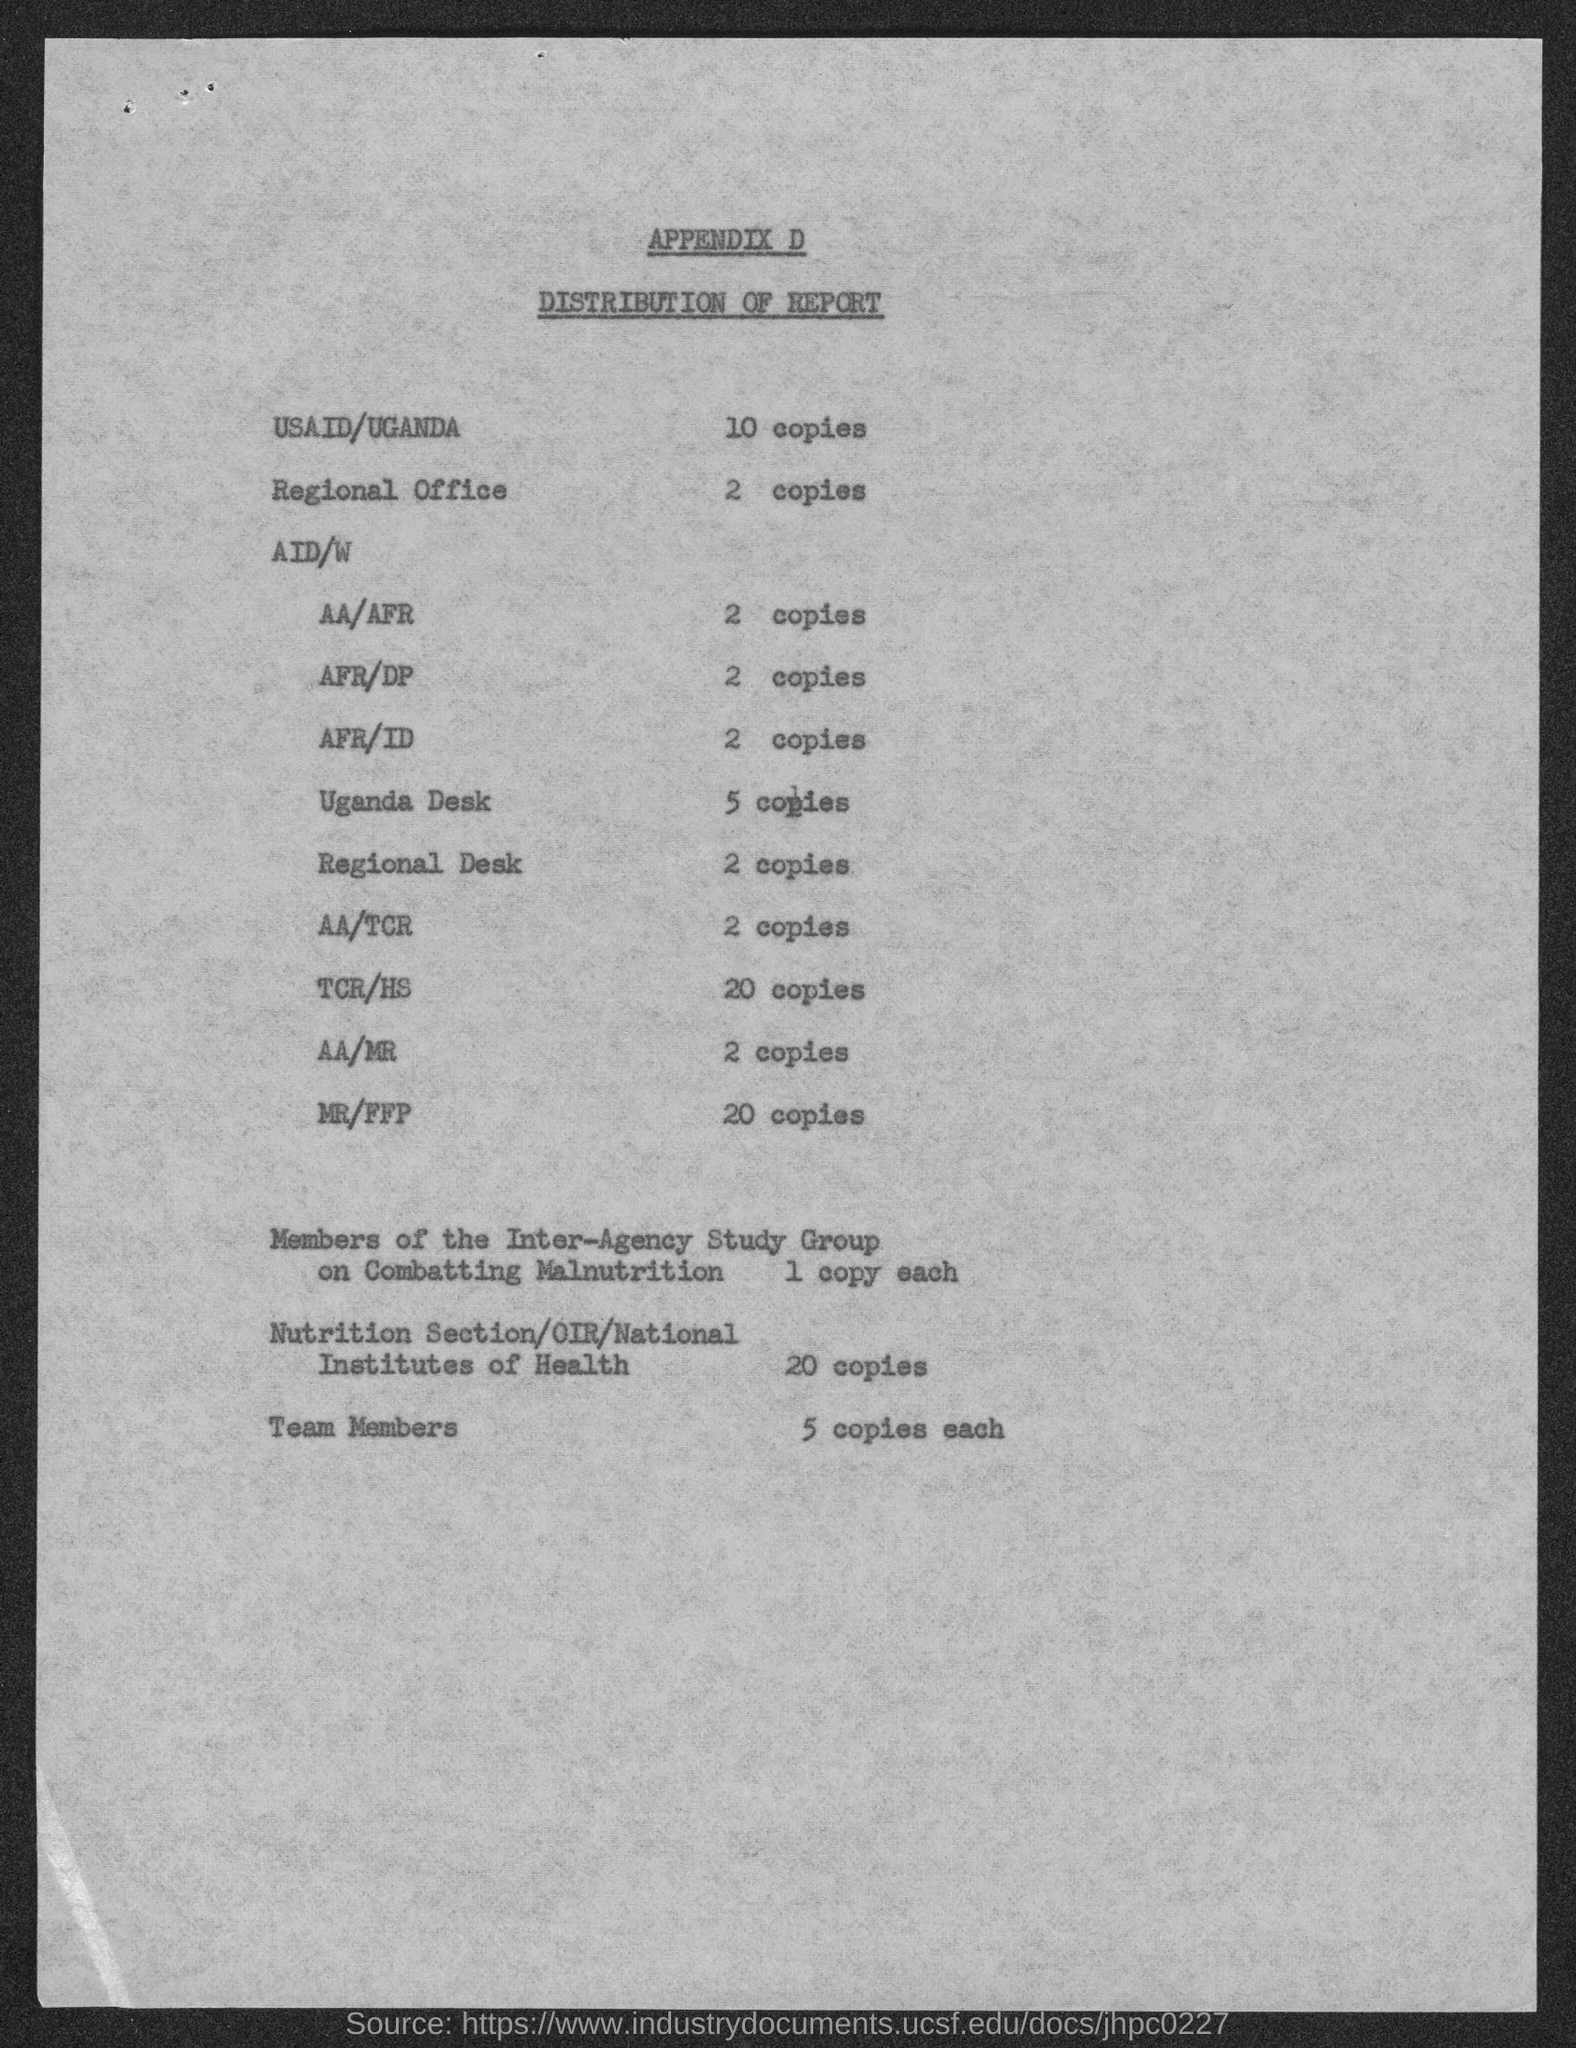What is the no of copies of the report distributed in the regional desk?
Your answer should be very brief. 2 copies. What is the no of copies of the report distributed in USAID/UGANDA?
Provide a short and direct response. 10. How many copies of the report are distributed in the Uganda Desk?
Provide a succinct answer. 5. How many copies of the report are distributed in AA/AFR?
Keep it short and to the point. 2. How many copies of the report are distributed to the team members?
Provide a succinct answer. 5 copies each. What is the no of copies of the report distributed in the regional office?
Keep it short and to the point. 2. 